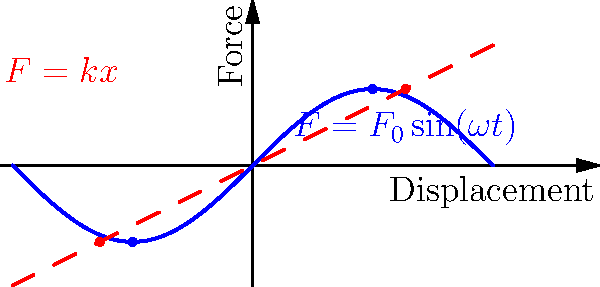In the force-displacement diagram of a spring-mass system under harmonic oscillation, we observe two distinct curves: a sinusoidal curve (blue) representing the applied force, and a linear curve (red) representing the spring's restoring force. How does this visualization relate to the concept of resonance in mechanical systems, and what cinematic techniques might be employed to visually represent this phenomenon in an avant-garde European film? To understand this question, let's break it down step-by-step:

1) The blue sinusoidal curve represents the applied force $F = F_0 \sin(\omega t)$, where $F_0$ is the amplitude, $\omega$ is the angular frequency, and $t$ is time.

2) The red linear curve represents the spring's restoring force $F = kx$, where $k$ is the spring constant and $x$ is the displacement.

3) Resonance occurs when the driving frequency $\omega$ matches the natural frequency $\omega_n$ of the system, where $\omega_n = \sqrt{\frac{k}{m}}$ (m is the mass).

4) At resonance, the amplitude of oscillation reaches its maximum, which would be represented by the blue curve having a larger amplitude.

5) In terms of cinematography, this phenomenon could be visually represented through:
   a) Slow-motion techniques to emphasize the increasing amplitude of oscillations
   b) Superimposition of the force-displacement curves over real-world objects
   c) Color grading that intensifies as the system approaches resonance
   d) Split-screen effects showing both the microscopic spring behavior and macroscopic system effects

6) Avant-garde European filmmakers like Jean-Luc Godard or Michelangelo Antonioni might use these visual representations metaphorically, perhaps to illustrate social or emotional resonance in their narratives.
Answer: Resonance occurs when driving frequency matches system's natural frequency; could be visually represented through slow-motion, superimposition, color grading, and split-screen techniques in avant-garde cinema. 